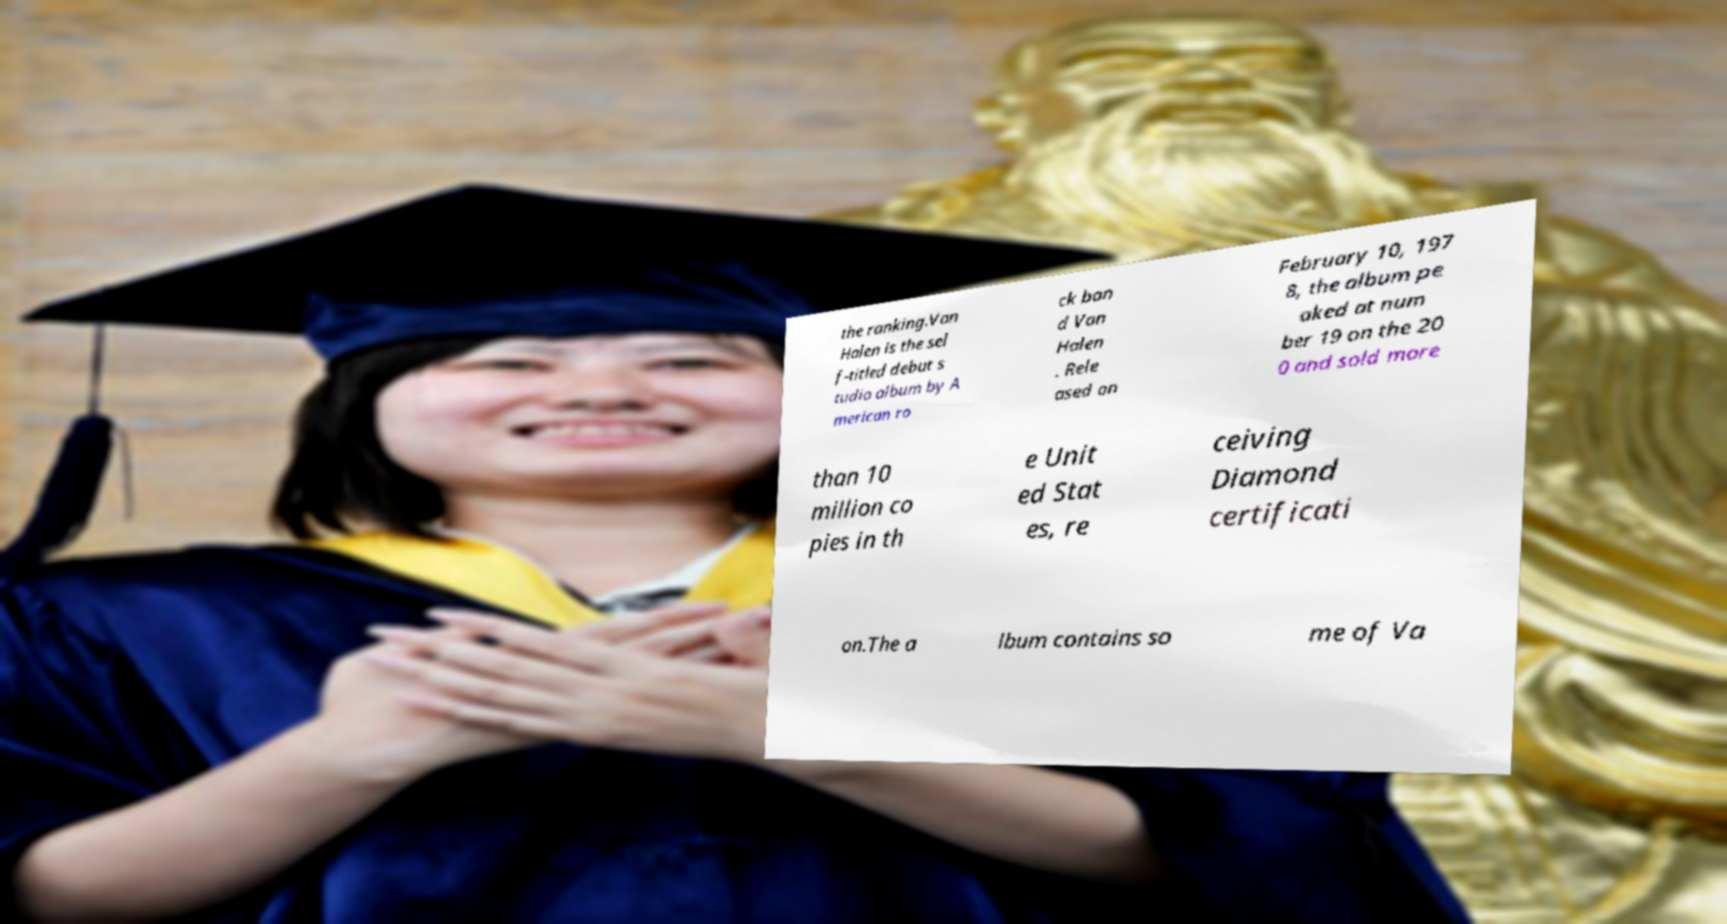There's text embedded in this image that I need extracted. Can you transcribe it verbatim? the ranking.Van Halen is the sel f-titled debut s tudio album by A merican ro ck ban d Van Halen . Rele ased on February 10, 197 8, the album pe aked at num ber 19 on the 20 0 and sold more than 10 million co pies in th e Unit ed Stat es, re ceiving Diamond certificati on.The a lbum contains so me of Va 